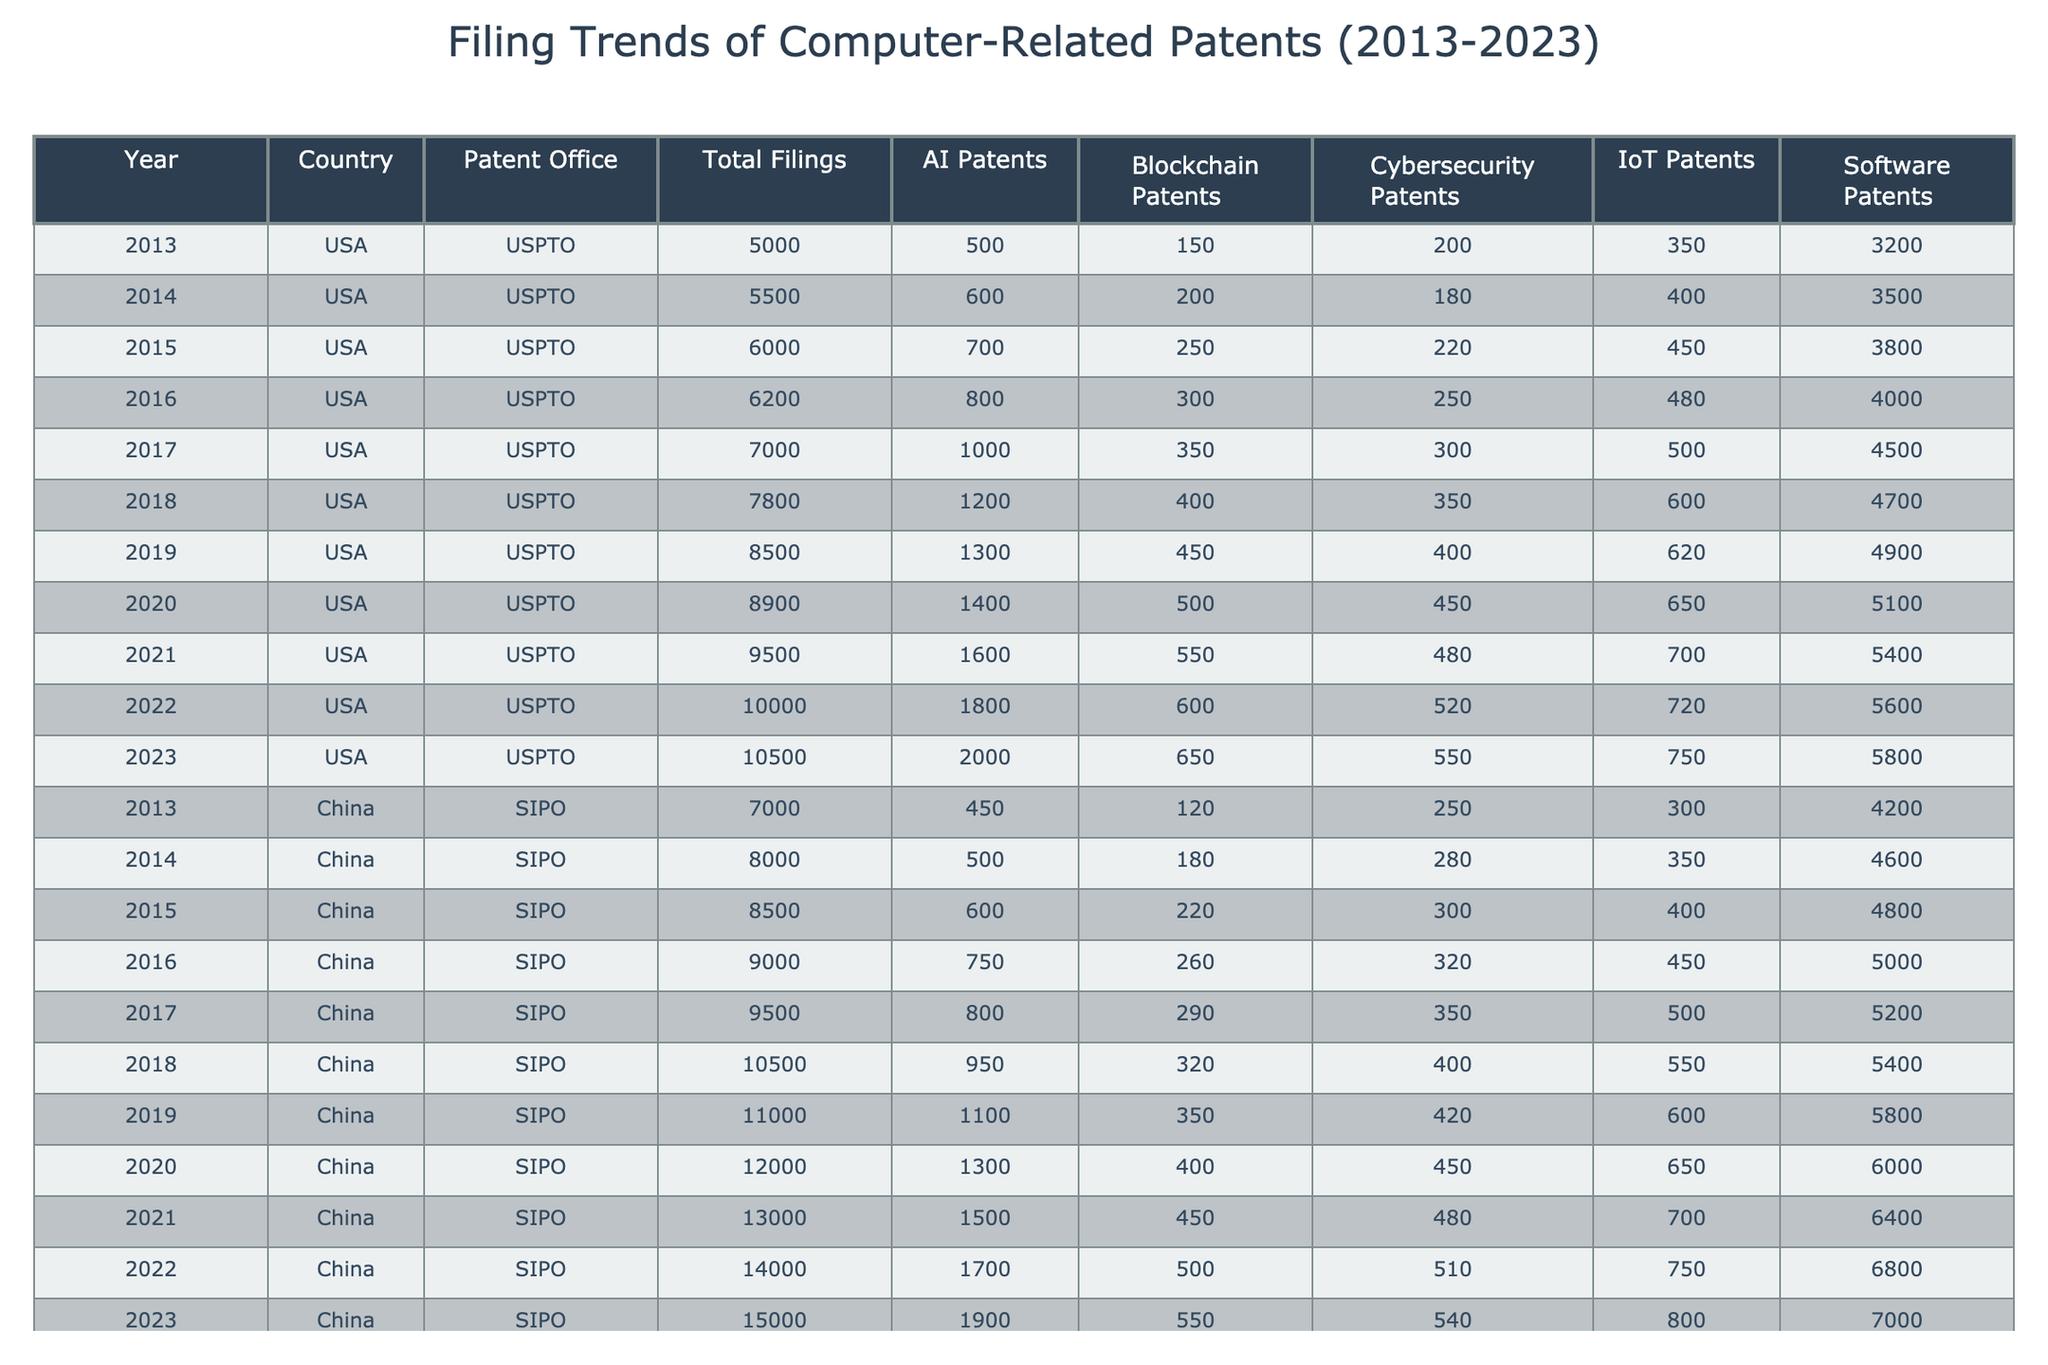What year saw the highest total filings for computer-related patents in the USA? By examining the "Total Filings" column for the USA, the highest figure is 10,500, which corresponds to the year 2023.
Answer: 2023 Which country had the highest number of AI patents filed in 2022? Looking at the "AI Patents" column for the year 2022, China had 1,700 AI patents filed, which is higher than the USA's 1,800.
Answer: China What was the total number of IoT patents filed in Europe from 2013 to 2023? To find the total, we add the IoT patents from each year in the European data: 150 + 170 + 190 + 200 + 220 + 240 + 260 + 280 + 310 + 370 = 2,373.
Answer: 2,373 Did the total filings for blockchain patents in the USA increase every year from 2013 to 2023? Upon reviewing the "Blockchain Patents" column, the numbers show a consistent increase: 150, 200, 250, 300, 350, 400, 450, 500, 550, 600 for the respective years, indicating a yes.
Answer: Yes What is the percentage increase in total filings for computer-related patents in China between 2013 and 2023? The total filings increased from 7,000 in 2013 to 15,000 in 2023. The percentage increase is calculated as ((15,000 - 7,000) / 7,000) * 100 = 114.29%.
Answer: 114.29% What was the average number of software patents filed annually in the USA from 2013 to 2023? Summing the software patents: 3,200 + 3,500 + 3,800 + 4,000 + 4,500 + 4,700 + 4,900 + 5,100 + 5,400 + 5,800 = 49,100. Since there are 11 years, the average is 49,100 / 11 = 4,463.64.
Answer: 4,463.64 In what year did both AI and blockchain patents reach their maximum in the USA? By reviewing the "AI Patents" and "Blockchain Patents" columns, the maximum figures are 2,000 and 650 respectively, both occurring in 2023.
Answer: 2023 What were the cybersecurity patent filings in 2020 versus 2021 in China? In the "Cybersecurity Patents" column for China, 2020 had 450 filings and 2021 had 480, which indicates an increase of 30.
Answer: 30 Was there ever a year when Europe did not report growth in total filings for computer-related patents? Observing the "Total Filings" for Europe: 3000, 3200, 3400, 3600, 3800, 4200, 4600, 5000, 5400, 5800, 6200 shows consistent growth each year, leading to a no answer.
Answer: No 